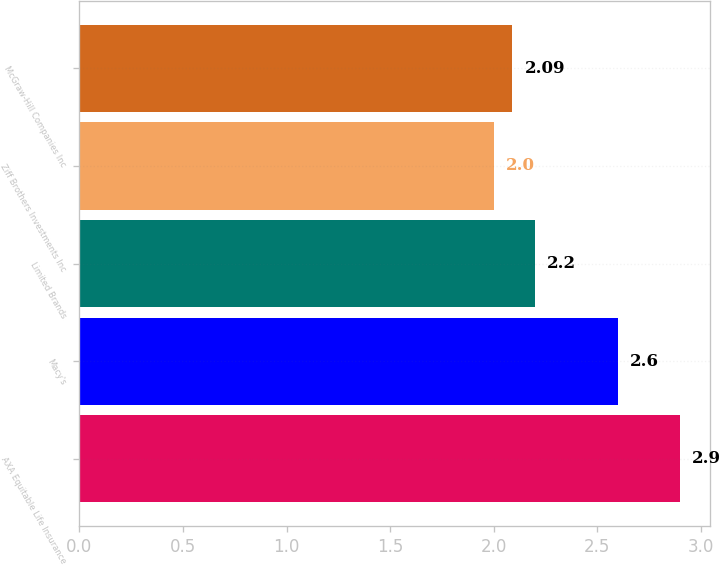Convert chart to OTSL. <chart><loc_0><loc_0><loc_500><loc_500><bar_chart><fcel>AXA Equitable Life Insurance<fcel>Macy's<fcel>Limited Brands<fcel>Ziff Brothers Investments Inc<fcel>McGraw-Hill Companies Inc<nl><fcel>2.9<fcel>2.6<fcel>2.2<fcel>2<fcel>2.09<nl></chart> 